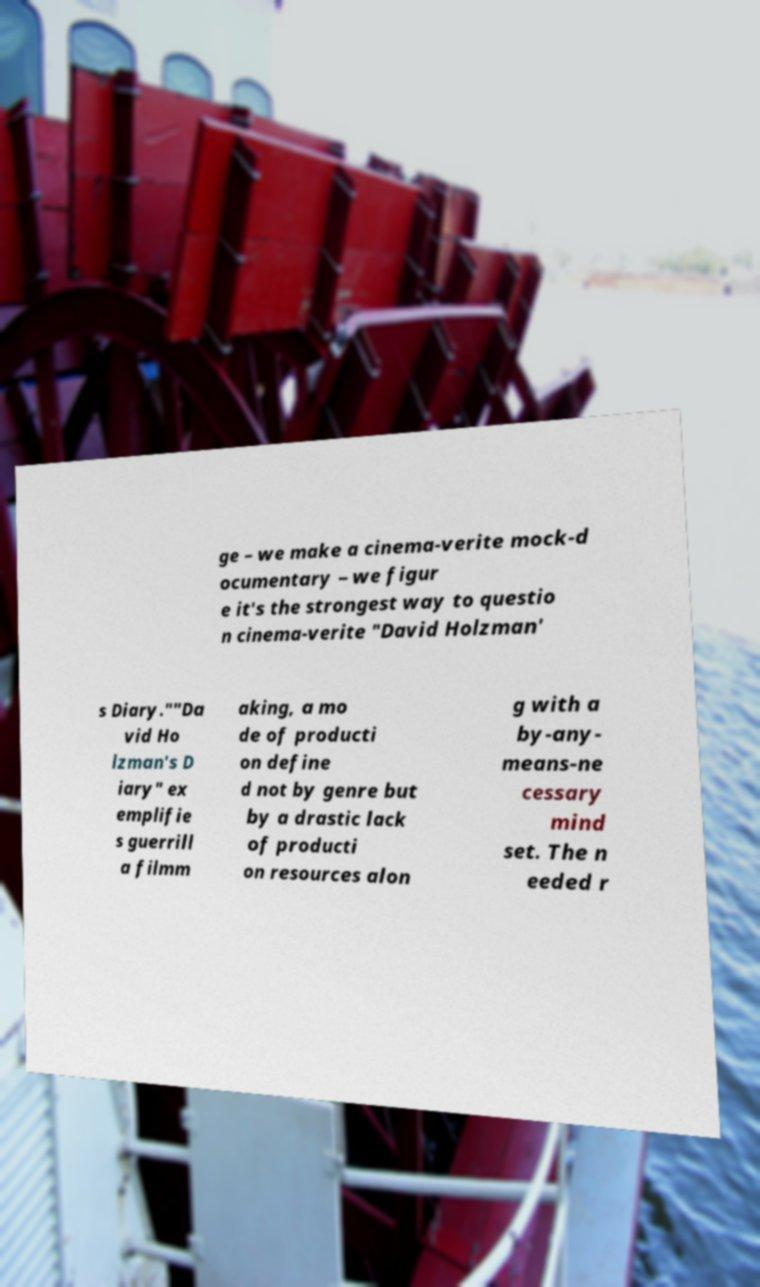Please identify and transcribe the text found in this image. ge – we make a cinema-verite mock-d ocumentary – we figur e it's the strongest way to questio n cinema-verite "David Holzman' s Diary.""Da vid Ho lzman's D iary" ex emplifie s guerrill a filmm aking, a mo de of producti on define d not by genre but by a drastic lack of producti on resources alon g with a by-any- means-ne cessary mind set. The n eeded r 